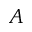<formula> <loc_0><loc_0><loc_500><loc_500>A</formula> 